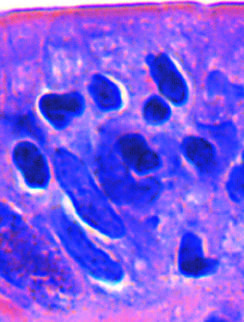what can infiltration of the surface epithelium by t lymphocytes be recognized by?
Answer the question using a single word or phrase. Densely stained nuclei 